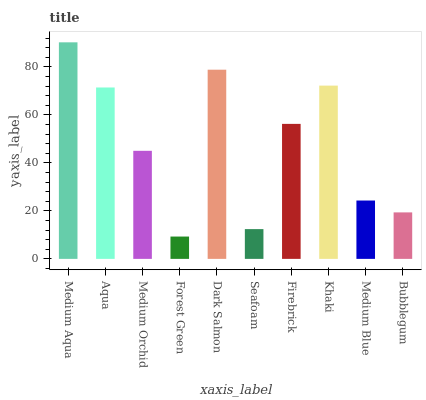Is Forest Green the minimum?
Answer yes or no. Yes. Is Medium Aqua the maximum?
Answer yes or no. Yes. Is Aqua the minimum?
Answer yes or no. No. Is Aqua the maximum?
Answer yes or no. No. Is Medium Aqua greater than Aqua?
Answer yes or no. Yes. Is Aqua less than Medium Aqua?
Answer yes or no. Yes. Is Aqua greater than Medium Aqua?
Answer yes or no. No. Is Medium Aqua less than Aqua?
Answer yes or no. No. Is Firebrick the high median?
Answer yes or no. Yes. Is Medium Orchid the low median?
Answer yes or no. Yes. Is Khaki the high median?
Answer yes or no. No. Is Khaki the low median?
Answer yes or no. No. 